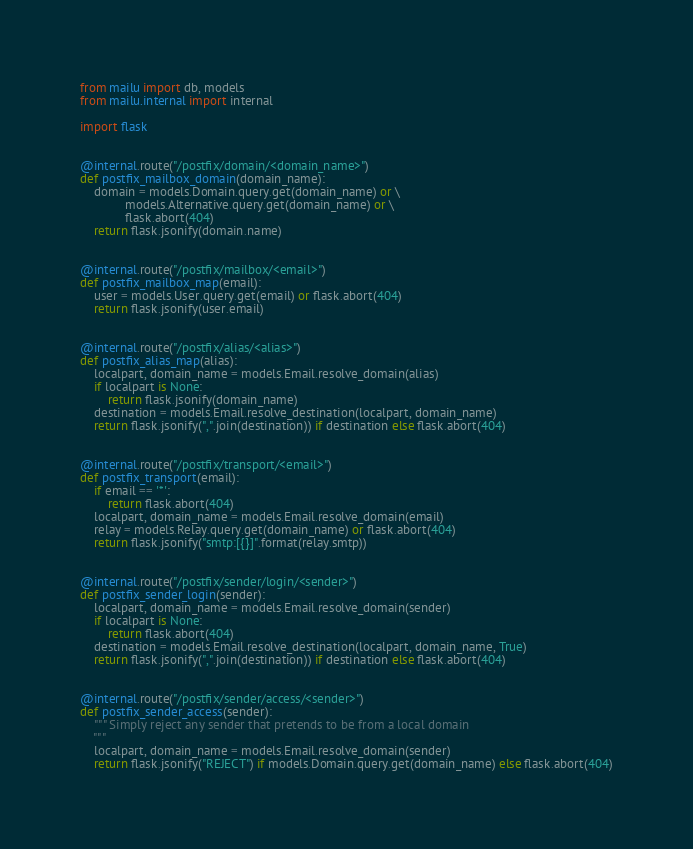<code> <loc_0><loc_0><loc_500><loc_500><_Python_>from mailu import db, models
from mailu.internal import internal

import flask


@internal.route("/postfix/domain/<domain_name>")
def postfix_mailbox_domain(domain_name):
    domain = models.Domain.query.get(domain_name) or \
             models.Alternative.query.get(domain_name) or \
             flask.abort(404)
    return flask.jsonify(domain.name)


@internal.route("/postfix/mailbox/<email>")
def postfix_mailbox_map(email):
    user = models.User.query.get(email) or flask.abort(404)
    return flask.jsonify(user.email)


@internal.route("/postfix/alias/<alias>")
def postfix_alias_map(alias):
    localpart, domain_name = models.Email.resolve_domain(alias)
    if localpart is None:
        return flask.jsonify(domain_name)
    destination = models.Email.resolve_destination(localpart, domain_name)
    return flask.jsonify(",".join(destination)) if destination else flask.abort(404)


@internal.route("/postfix/transport/<email>")
def postfix_transport(email):
    if email == '*':
        return flask.abort(404)
    localpart, domain_name = models.Email.resolve_domain(email)
    relay = models.Relay.query.get(domain_name) or flask.abort(404)
    return flask.jsonify("smtp:[{}]".format(relay.smtp))


@internal.route("/postfix/sender/login/<sender>")
def postfix_sender_login(sender):
    localpart, domain_name = models.Email.resolve_domain(sender)
    if localpart is None:
        return flask.abort(404)
    destination = models.Email.resolve_destination(localpart, domain_name, True)
    return flask.jsonify(",".join(destination)) if destination else flask.abort(404)


@internal.route("/postfix/sender/access/<sender>")
def postfix_sender_access(sender):
    """ Simply reject any sender that pretends to be from a local domain
    """
    localpart, domain_name = models.Email.resolve_domain(sender)
    return flask.jsonify("REJECT") if models.Domain.query.get(domain_name) else flask.abort(404)
</code> 